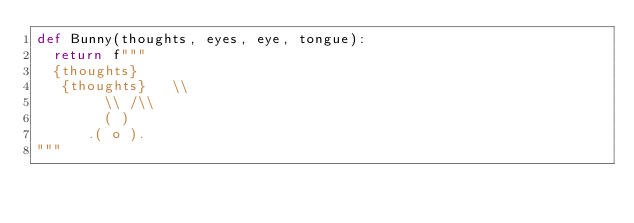Convert code to text. <code><loc_0><loc_0><loc_500><loc_500><_Python_>def Bunny(thoughts, eyes, eye, tongue):
  return f"""
  {thoughts}
   {thoughts}   \\
        \\ /\\
        ( )
      .( o ).
"""</code> 